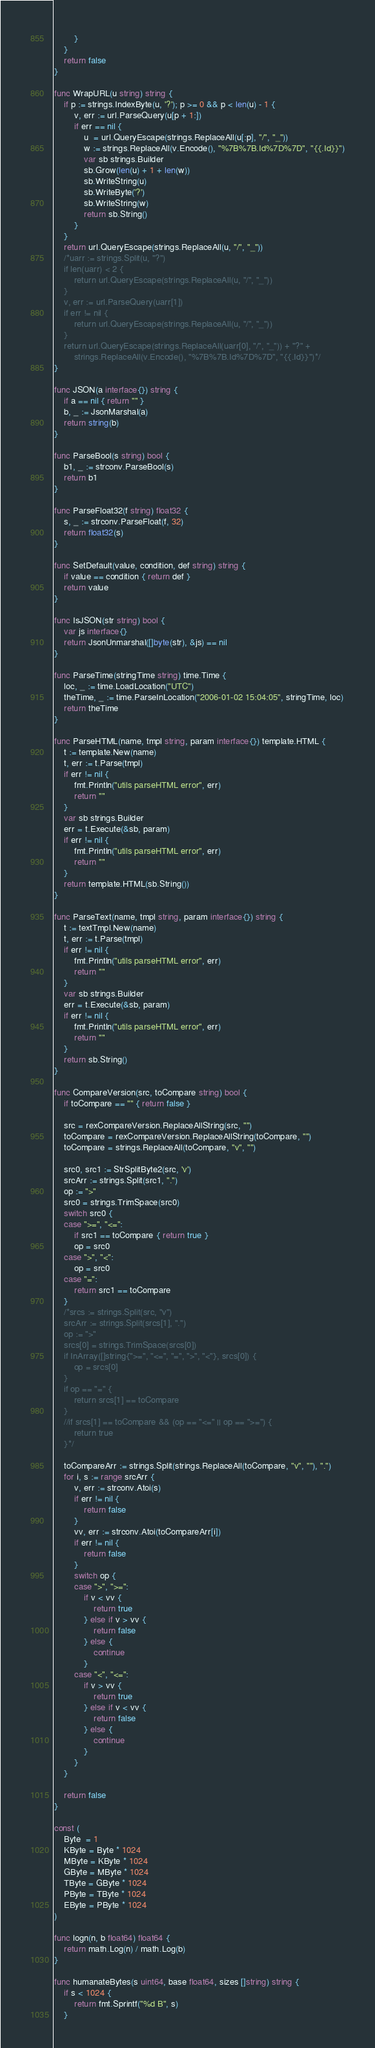Convert code to text. <code><loc_0><loc_0><loc_500><loc_500><_Go_>		}
	}
	return false
}

func WrapURL(u string) string {
	if p := strings.IndexByte(u, '?'); p >= 0 && p < len(u) - 1 {
		v, err := url.ParseQuery(u[p + 1:])
		if err == nil {
			u  = url.QueryEscape(strings.ReplaceAll(u[:p], "/", "_"))
			w := strings.ReplaceAll(v.Encode(), "%7B%7B.Id%7D%7D", "{{.Id}}")
			var sb strings.Builder
			sb.Grow(len(u) + 1 + len(w))
			sb.WriteString(u)
			sb.WriteByte('?')
			sb.WriteString(w)
			return sb.String()
		}
	}
	return url.QueryEscape(strings.ReplaceAll(u, "/", "_"))
	/*uarr := strings.Split(u, "?")
	if len(uarr) < 2 {
		return url.QueryEscape(strings.ReplaceAll(u, "/", "_"))
	}
	v, err := url.ParseQuery(uarr[1])
	if err != nil {
		return url.QueryEscape(strings.ReplaceAll(u, "/", "_"))
	}
	return url.QueryEscape(strings.ReplaceAll(uarr[0], "/", "_")) + "?" +
		strings.ReplaceAll(v.Encode(), "%7B%7B.Id%7D%7D", "{{.Id}}")*/
}

func JSON(a interface{}) string {
	if a == nil { return "" }
	b, _ := JsonMarshal(a)
	return string(b)
}

func ParseBool(s string) bool {
	b1, _ := strconv.ParseBool(s)
	return b1
}

func ParseFloat32(f string) float32 {
	s, _ := strconv.ParseFloat(f, 32)
	return float32(s)
}

func SetDefault(value, condition, def string) string {
	if value == condition { return def }
	return value
}

func IsJSON(str string) bool {
	var js interface{}
	return JsonUnmarshal([]byte(str), &js) == nil
}

func ParseTime(stringTime string) time.Time {
	loc, _ := time.LoadLocation("UTC")
	theTime, _ := time.ParseInLocation("2006-01-02 15:04:05", stringTime, loc)
	return theTime
}

func ParseHTML(name, tmpl string, param interface{}) template.HTML {
	t := template.New(name)
	t, err := t.Parse(tmpl)
	if err != nil {
		fmt.Println("utils parseHTML error", err)
		return ""
	}
	var sb strings.Builder
	err = t.Execute(&sb, param)
	if err != nil {
		fmt.Println("utils parseHTML error", err)
		return ""
	}
	return template.HTML(sb.String())
}

func ParseText(name, tmpl string, param interface{}) string {
	t := textTmpl.New(name)
	t, err := t.Parse(tmpl)
	if err != nil {
		fmt.Println("utils parseHTML error", err)
		return ""
	}
	var sb strings.Builder
	err = t.Execute(&sb, param)
	if err != nil {
		fmt.Println("utils parseHTML error", err)
		return ""
	}
	return sb.String()
}

func CompareVersion(src, toCompare string) bool {
	if toCompare == "" { return false }

	src = rexCompareVersion.ReplaceAllString(src, "")
	toCompare = rexCompareVersion.ReplaceAllString(toCompare, "")
	toCompare = strings.ReplaceAll(toCompare, "v", "")

	src0, src1 := StrSplitByte2(src, 'v')
	srcArr := strings.Split(src1, ".")
	op := ">"
	src0 = strings.TrimSpace(src0)
	switch src0 {
	case ">=", "<=":
		if src1 == toCompare { return true }
		op = src0
	case ">", "<":
		op = src0
	case "=":
		return src1 == toCompare
	}
	/*srcs := strings.Split(src, "v")
	srcArr := strings.Split(srcs[1], ".")
	op := ">"
	srcs[0] = strings.TrimSpace(srcs[0])
	if InArray([]string{">=", "<=", "=", ">", "<"}, srcs[0]) {
		op = srcs[0]
	}
	if op == "=" {
		return srcs[1] == toCompare
	}
	//if srcs[1] == toCompare && (op == "<=" || op == ">=") {
		return true
	}*/

	toCompareArr := strings.Split(strings.ReplaceAll(toCompare, "v", ""), ".")
	for i, s := range srcArr {
		v, err := strconv.Atoi(s)
		if err != nil {
			return false
		}
		vv, err := strconv.Atoi(toCompareArr[i])
		if err != nil {
			return false
		}
		switch op {
		case ">", ">=":
			if v < vv {
				return true
			} else if v > vv {
				return false
			} else {
				continue
			}
		case "<", "<=":
			if v > vv {
				return true
			} else if v < vv {
				return false
			} else {
				continue
			}
		}
	}

	return false
}

const (
	Byte  = 1
	KByte = Byte * 1024
	MByte = KByte * 1024
	GByte = MByte * 1024
	TByte = GByte * 1024
	PByte = TByte * 1024
	EByte = PByte * 1024
)

func logn(n, b float64) float64 {
	return math.Log(n) / math.Log(b)
}

func humanateBytes(s uint64, base float64, sizes []string) string {
	if s < 1024 {
		return fmt.Sprintf("%d B", s)
	}</code> 